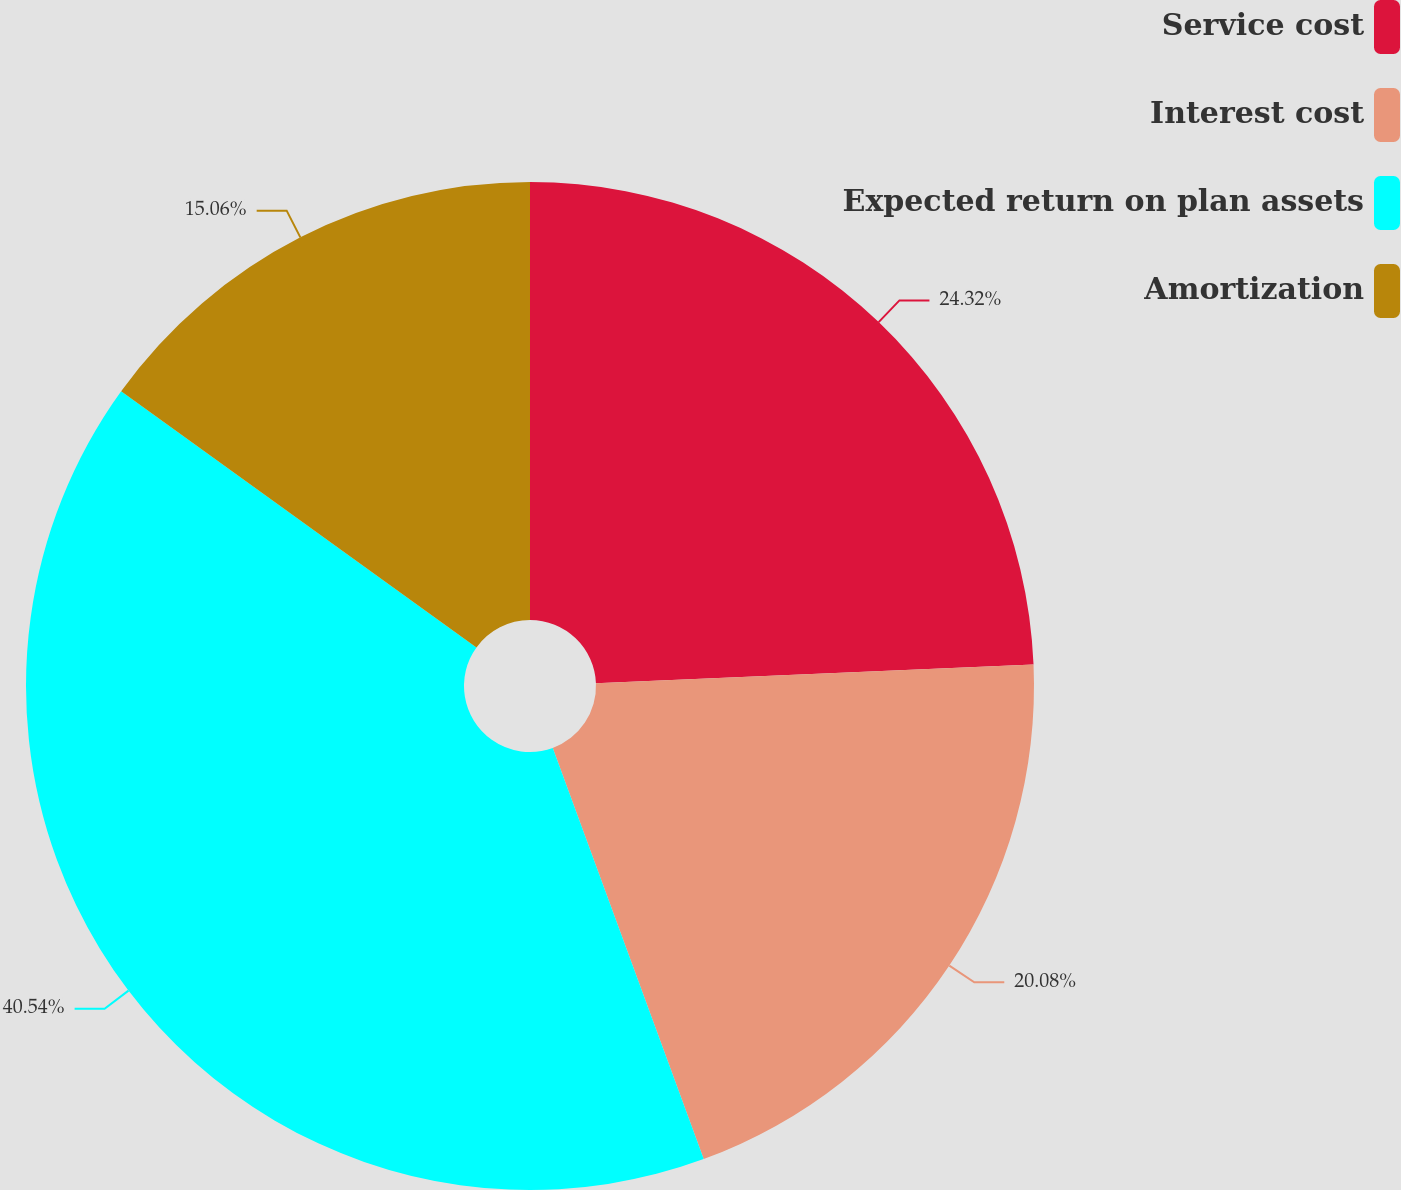Convert chart. <chart><loc_0><loc_0><loc_500><loc_500><pie_chart><fcel>Service cost<fcel>Interest cost<fcel>Expected return on plan assets<fcel>Amortization<nl><fcel>24.32%<fcel>20.08%<fcel>40.54%<fcel>15.06%<nl></chart> 